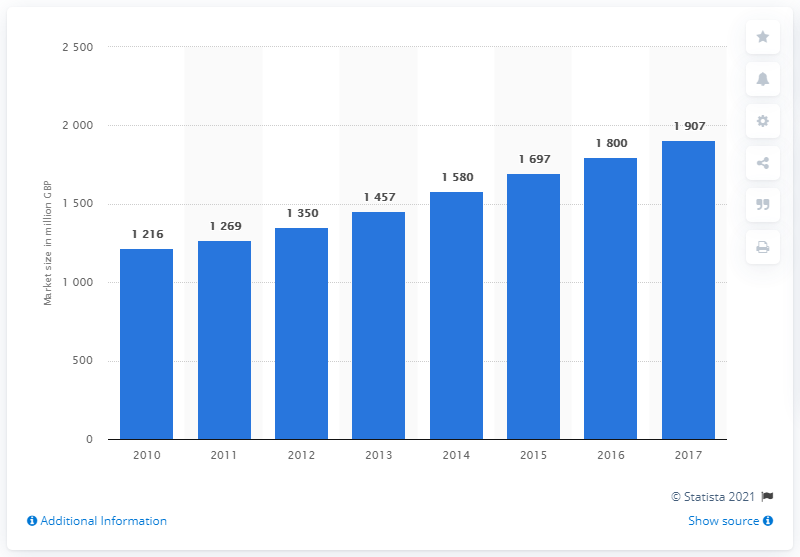Identify some key points in this picture. In 2017, the estimated size of the cyber security market within the total software and IT services segment was approximately 1907. The cyber security market in the UK began to grow in 2010. The median market size value for the years 2013 to 2017 was 1697 million GBP. In 2010, the cyber security market size of software and IT services was approximately 1216 million British pounds. 